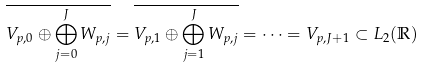<formula> <loc_0><loc_0><loc_500><loc_500>\overline { V _ { p , 0 } \oplus \bigoplus _ { j = 0 } ^ { J } W _ { p , j } } = \overline { V _ { p , 1 } \oplus \bigoplus _ { j = 1 } ^ { J } W _ { p , j } } = \dots = V _ { p , J + 1 } \subset L _ { 2 } ( \mathbb { R } )</formula> 